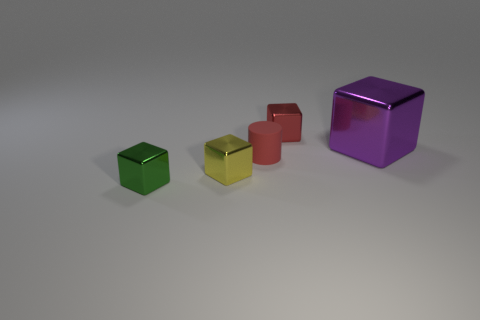Subtract 1 blocks. How many blocks are left? 3 Add 3 large brown metallic spheres. How many objects exist? 8 Subtract all blocks. How many objects are left? 1 Subtract all green shiny blocks. Subtract all tiny blue matte things. How many objects are left? 4 Add 1 tiny yellow metal cubes. How many tiny yellow metal cubes are left? 2 Add 2 brown blocks. How many brown blocks exist? 2 Subtract 0 purple balls. How many objects are left? 5 